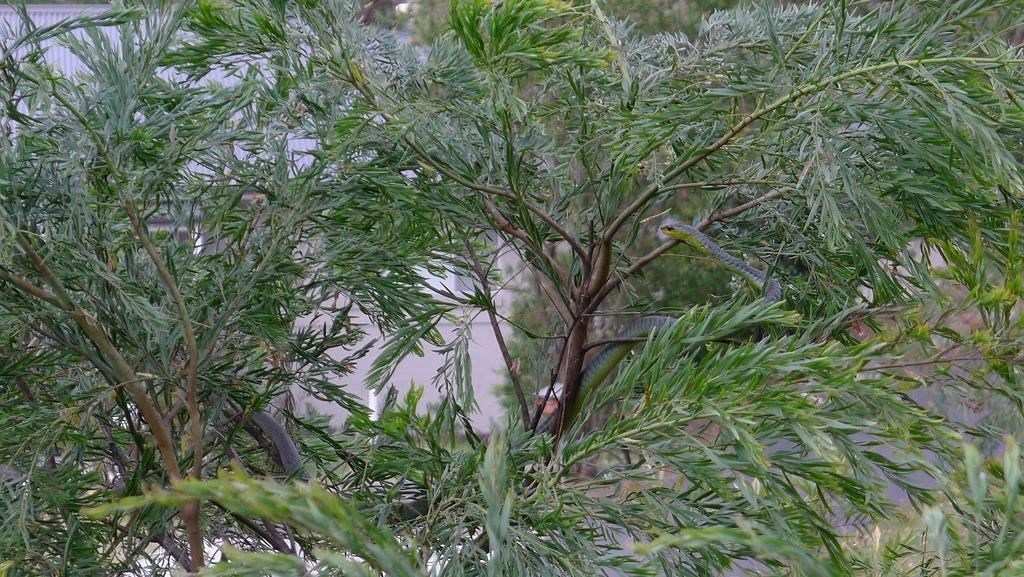What animal is present in the image? There is a snake in the image. Where is the snake located? The snake is on a tree. What is the weight of the pig in the image? There is no pig present in the image, so it is not possible to determine its weight. 